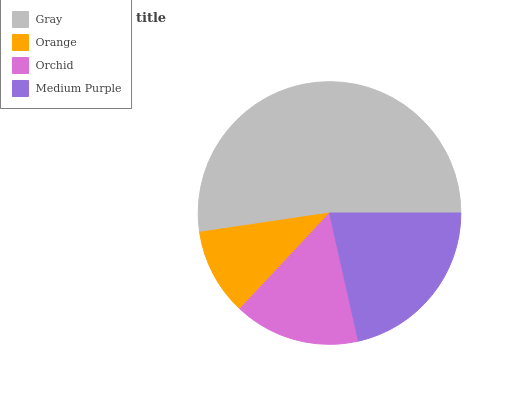Is Orange the minimum?
Answer yes or no. Yes. Is Gray the maximum?
Answer yes or no. Yes. Is Orchid the minimum?
Answer yes or no. No. Is Orchid the maximum?
Answer yes or no. No. Is Orchid greater than Orange?
Answer yes or no. Yes. Is Orange less than Orchid?
Answer yes or no. Yes. Is Orange greater than Orchid?
Answer yes or no. No. Is Orchid less than Orange?
Answer yes or no. No. Is Medium Purple the high median?
Answer yes or no. Yes. Is Orchid the low median?
Answer yes or no. Yes. Is Orange the high median?
Answer yes or no. No. Is Medium Purple the low median?
Answer yes or no. No. 